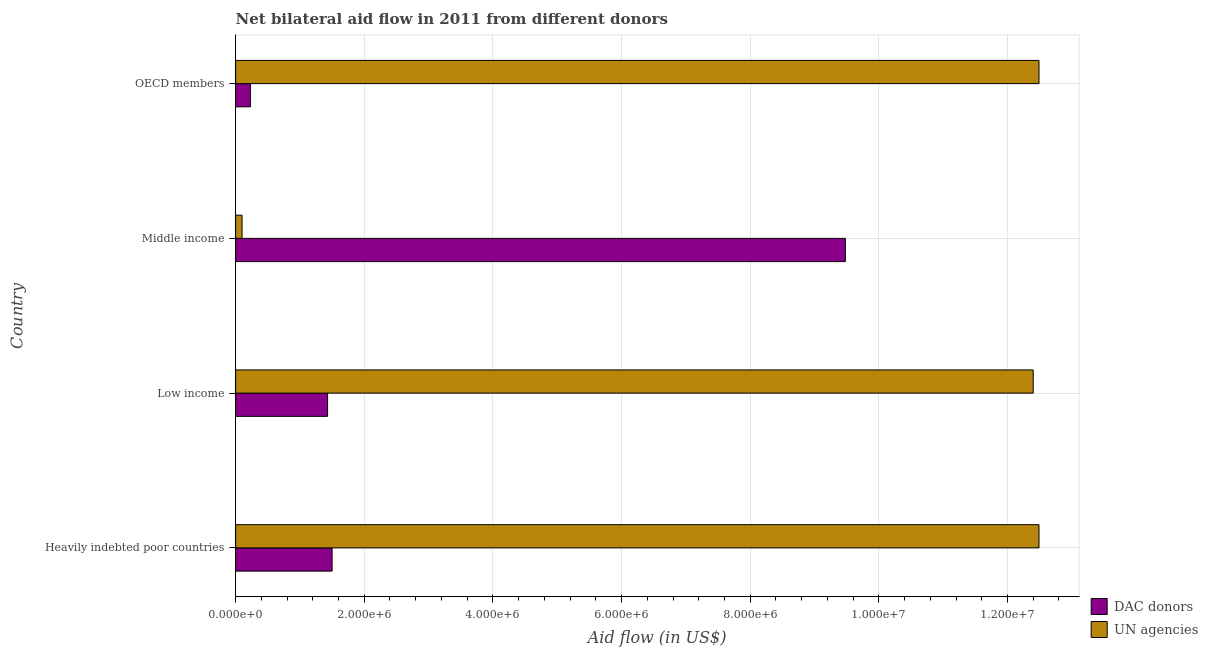How many different coloured bars are there?
Offer a very short reply. 2. Are the number of bars per tick equal to the number of legend labels?
Make the answer very short. Yes. How many bars are there on the 2nd tick from the bottom?
Your answer should be very brief. 2. What is the label of the 2nd group of bars from the top?
Your answer should be very brief. Middle income. What is the aid flow from dac donors in Heavily indebted poor countries?
Your response must be concise. 1.50e+06. Across all countries, what is the maximum aid flow from un agencies?
Offer a very short reply. 1.25e+07. Across all countries, what is the minimum aid flow from dac donors?
Your response must be concise. 2.30e+05. In which country was the aid flow from dac donors maximum?
Keep it short and to the point. Middle income. What is the total aid flow from dac donors in the graph?
Your answer should be compact. 1.26e+07. What is the difference between the aid flow from un agencies in Low income and that in Middle income?
Provide a short and direct response. 1.23e+07. What is the difference between the aid flow from un agencies in Middle income and the aid flow from dac donors in OECD members?
Offer a very short reply. -1.30e+05. What is the average aid flow from un agencies per country?
Your response must be concise. 9.37e+06. What is the difference between the aid flow from dac donors and aid flow from un agencies in OECD members?
Keep it short and to the point. -1.23e+07. What is the ratio of the aid flow from dac donors in Middle income to that in OECD members?
Keep it short and to the point. 41.22. Is the aid flow from un agencies in Low income less than that in OECD members?
Offer a terse response. Yes. What is the difference between the highest and the second highest aid flow from dac donors?
Ensure brevity in your answer.  7.98e+06. What is the difference between the highest and the lowest aid flow from dac donors?
Provide a succinct answer. 9.25e+06. In how many countries, is the aid flow from un agencies greater than the average aid flow from un agencies taken over all countries?
Offer a very short reply. 3. What does the 2nd bar from the top in OECD members represents?
Your answer should be very brief. DAC donors. What does the 2nd bar from the bottom in Low income represents?
Provide a succinct answer. UN agencies. How many bars are there?
Keep it short and to the point. 8. Are all the bars in the graph horizontal?
Your answer should be compact. Yes. How many countries are there in the graph?
Your answer should be very brief. 4. What is the difference between two consecutive major ticks on the X-axis?
Make the answer very short. 2.00e+06. Are the values on the major ticks of X-axis written in scientific E-notation?
Your answer should be very brief. Yes. How many legend labels are there?
Provide a succinct answer. 2. How are the legend labels stacked?
Offer a very short reply. Vertical. What is the title of the graph?
Give a very brief answer. Net bilateral aid flow in 2011 from different donors. Does "GDP" appear as one of the legend labels in the graph?
Your answer should be very brief. No. What is the label or title of the X-axis?
Offer a terse response. Aid flow (in US$). What is the label or title of the Y-axis?
Give a very brief answer. Country. What is the Aid flow (in US$) in DAC donors in Heavily indebted poor countries?
Offer a terse response. 1.50e+06. What is the Aid flow (in US$) of UN agencies in Heavily indebted poor countries?
Your answer should be compact. 1.25e+07. What is the Aid flow (in US$) in DAC donors in Low income?
Offer a very short reply. 1.43e+06. What is the Aid flow (in US$) of UN agencies in Low income?
Your response must be concise. 1.24e+07. What is the Aid flow (in US$) of DAC donors in Middle income?
Give a very brief answer. 9.48e+06. What is the Aid flow (in US$) in UN agencies in Middle income?
Give a very brief answer. 1.00e+05. What is the Aid flow (in US$) in DAC donors in OECD members?
Your answer should be very brief. 2.30e+05. What is the Aid flow (in US$) of UN agencies in OECD members?
Provide a short and direct response. 1.25e+07. Across all countries, what is the maximum Aid flow (in US$) of DAC donors?
Offer a very short reply. 9.48e+06. Across all countries, what is the maximum Aid flow (in US$) in UN agencies?
Offer a terse response. 1.25e+07. Across all countries, what is the minimum Aid flow (in US$) in DAC donors?
Provide a short and direct response. 2.30e+05. What is the total Aid flow (in US$) in DAC donors in the graph?
Ensure brevity in your answer.  1.26e+07. What is the total Aid flow (in US$) of UN agencies in the graph?
Give a very brief answer. 3.75e+07. What is the difference between the Aid flow (in US$) of DAC donors in Heavily indebted poor countries and that in Middle income?
Keep it short and to the point. -7.98e+06. What is the difference between the Aid flow (in US$) of UN agencies in Heavily indebted poor countries and that in Middle income?
Ensure brevity in your answer.  1.24e+07. What is the difference between the Aid flow (in US$) in DAC donors in Heavily indebted poor countries and that in OECD members?
Provide a succinct answer. 1.27e+06. What is the difference between the Aid flow (in US$) in UN agencies in Heavily indebted poor countries and that in OECD members?
Provide a succinct answer. 0. What is the difference between the Aid flow (in US$) of DAC donors in Low income and that in Middle income?
Provide a short and direct response. -8.05e+06. What is the difference between the Aid flow (in US$) in UN agencies in Low income and that in Middle income?
Provide a short and direct response. 1.23e+07. What is the difference between the Aid flow (in US$) of DAC donors in Low income and that in OECD members?
Make the answer very short. 1.20e+06. What is the difference between the Aid flow (in US$) in UN agencies in Low income and that in OECD members?
Your answer should be compact. -9.00e+04. What is the difference between the Aid flow (in US$) of DAC donors in Middle income and that in OECD members?
Your answer should be very brief. 9.25e+06. What is the difference between the Aid flow (in US$) of UN agencies in Middle income and that in OECD members?
Your answer should be compact. -1.24e+07. What is the difference between the Aid flow (in US$) of DAC donors in Heavily indebted poor countries and the Aid flow (in US$) of UN agencies in Low income?
Offer a very short reply. -1.09e+07. What is the difference between the Aid flow (in US$) of DAC donors in Heavily indebted poor countries and the Aid flow (in US$) of UN agencies in Middle income?
Give a very brief answer. 1.40e+06. What is the difference between the Aid flow (in US$) in DAC donors in Heavily indebted poor countries and the Aid flow (in US$) in UN agencies in OECD members?
Your answer should be very brief. -1.10e+07. What is the difference between the Aid flow (in US$) of DAC donors in Low income and the Aid flow (in US$) of UN agencies in Middle income?
Your answer should be compact. 1.33e+06. What is the difference between the Aid flow (in US$) of DAC donors in Low income and the Aid flow (in US$) of UN agencies in OECD members?
Keep it short and to the point. -1.11e+07. What is the difference between the Aid flow (in US$) in DAC donors in Middle income and the Aid flow (in US$) in UN agencies in OECD members?
Give a very brief answer. -3.01e+06. What is the average Aid flow (in US$) of DAC donors per country?
Offer a terse response. 3.16e+06. What is the average Aid flow (in US$) of UN agencies per country?
Keep it short and to the point. 9.37e+06. What is the difference between the Aid flow (in US$) of DAC donors and Aid flow (in US$) of UN agencies in Heavily indebted poor countries?
Your answer should be compact. -1.10e+07. What is the difference between the Aid flow (in US$) in DAC donors and Aid flow (in US$) in UN agencies in Low income?
Provide a short and direct response. -1.10e+07. What is the difference between the Aid flow (in US$) in DAC donors and Aid flow (in US$) in UN agencies in Middle income?
Keep it short and to the point. 9.38e+06. What is the difference between the Aid flow (in US$) in DAC donors and Aid flow (in US$) in UN agencies in OECD members?
Offer a very short reply. -1.23e+07. What is the ratio of the Aid flow (in US$) of DAC donors in Heavily indebted poor countries to that in Low income?
Your response must be concise. 1.05. What is the ratio of the Aid flow (in US$) of UN agencies in Heavily indebted poor countries to that in Low income?
Offer a very short reply. 1.01. What is the ratio of the Aid flow (in US$) in DAC donors in Heavily indebted poor countries to that in Middle income?
Ensure brevity in your answer.  0.16. What is the ratio of the Aid flow (in US$) of UN agencies in Heavily indebted poor countries to that in Middle income?
Offer a terse response. 124.9. What is the ratio of the Aid flow (in US$) of DAC donors in Heavily indebted poor countries to that in OECD members?
Your answer should be compact. 6.52. What is the ratio of the Aid flow (in US$) in DAC donors in Low income to that in Middle income?
Ensure brevity in your answer.  0.15. What is the ratio of the Aid flow (in US$) in UN agencies in Low income to that in Middle income?
Offer a terse response. 124. What is the ratio of the Aid flow (in US$) of DAC donors in Low income to that in OECD members?
Your answer should be very brief. 6.22. What is the ratio of the Aid flow (in US$) of DAC donors in Middle income to that in OECD members?
Provide a short and direct response. 41.22. What is the ratio of the Aid flow (in US$) of UN agencies in Middle income to that in OECD members?
Provide a succinct answer. 0.01. What is the difference between the highest and the second highest Aid flow (in US$) of DAC donors?
Give a very brief answer. 7.98e+06. What is the difference between the highest and the lowest Aid flow (in US$) of DAC donors?
Offer a terse response. 9.25e+06. What is the difference between the highest and the lowest Aid flow (in US$) of UN agencies?
Ensure brevity in your answer.  1.24e+07. 